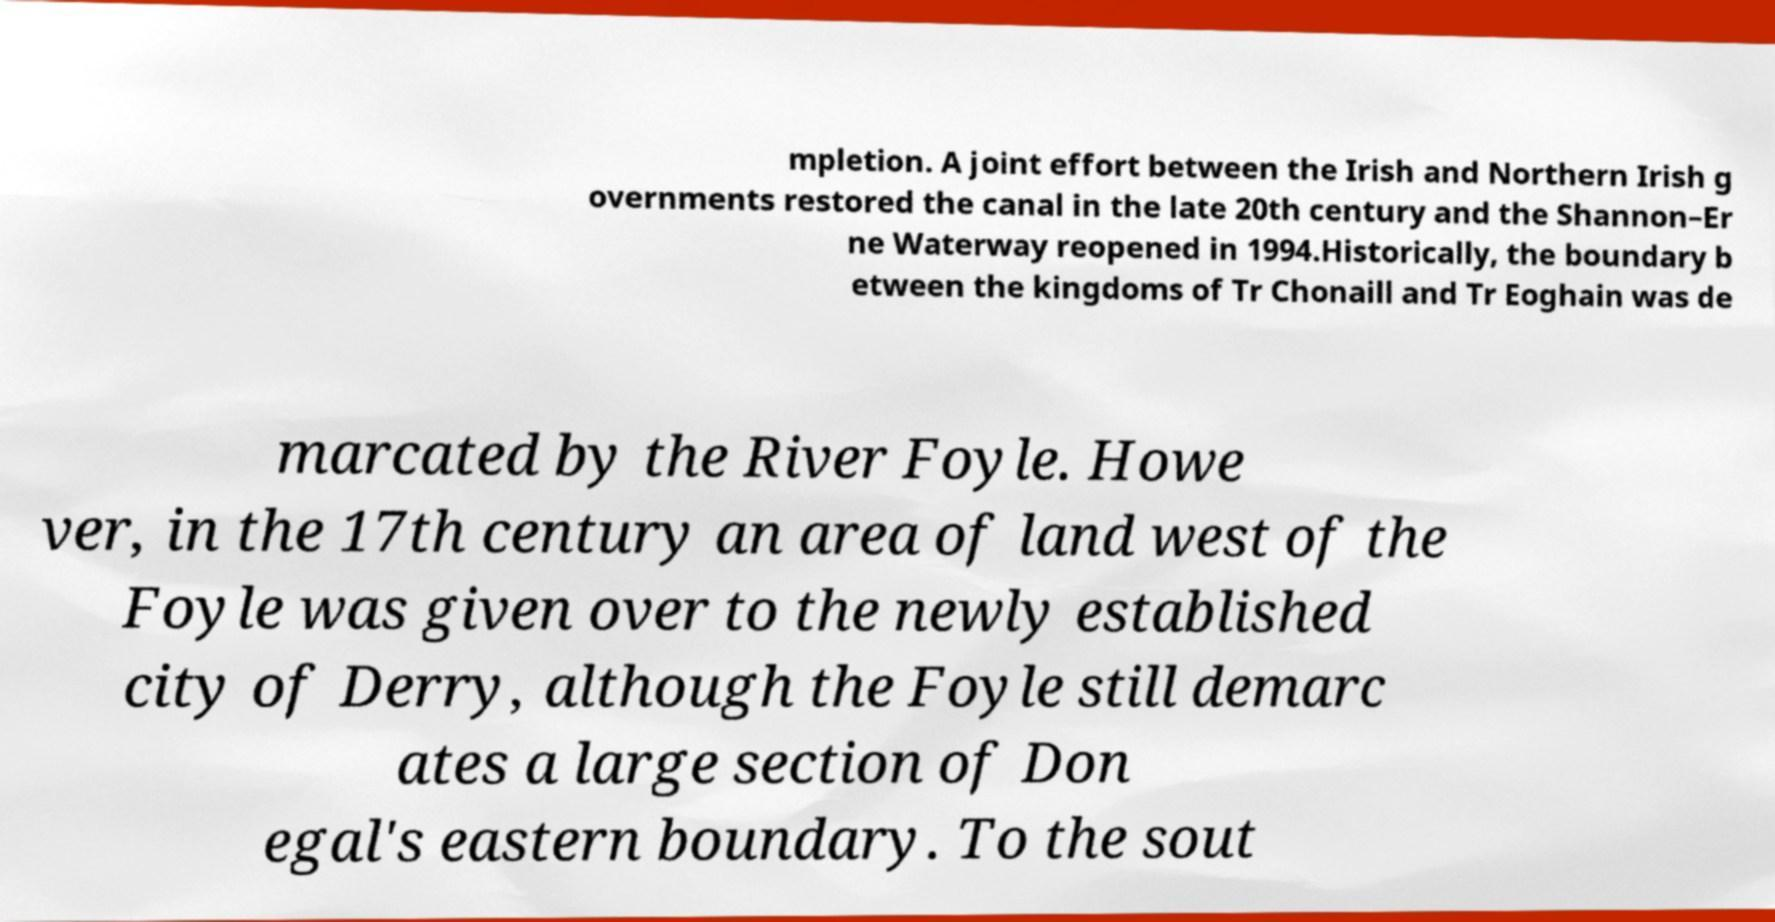I need the written content from this picture converted into text. Can you do that? mpletion. A joint effort between the Irish and Northern Irish g overnments restored the canal in the late 20th century and the Shannon–Er ne Waterway reopened in 1994.Historically, the boundary b etween the kingdoms of Tr Chonaill and Tr Eoghain was de marcated by the River Foyle. Howe ver, in the 17th century an area of land west of the Foyle was given over to the newly established city of Derry, although the Foyle still demarc ates a large section of Don egal's eastern boundary. To the sout 